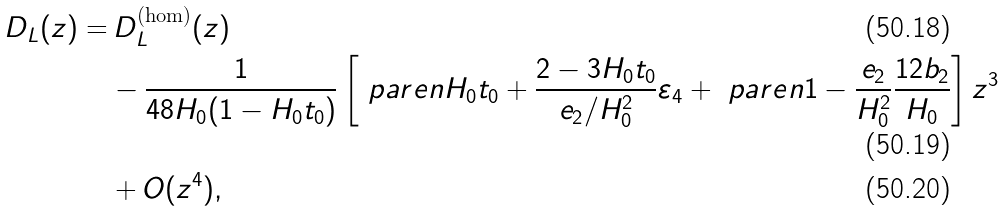Convert formula to latex. <formula><loc_0><loc_0><loc_500><loc_500>D _ { L } ( z ) = & \, D _ { L } ^ { \text {(hom)} } ( z ) \\ & - \frac { 1 } { 4 8 H _ { 0 } ( 1 - H _ { 0 } t _ { 0 } ) } \left [ \ p a r e n { H _ { 0 } t _ { 0 } + \frac { 2 - 3 H _ { 0 } t _ { 0 } } { e _ { 2 } / H _ { 0 } ^ { 2 } } } \varepsilon _ { 4 } + \ p a r e n { 1 - \frac { e _ { 2 } } { H _ { 0 } ^ { 2 } } } \frac { 1 2 b _ { 2 } } { H _ { 0 } } \right ] z ^ { 3 } \\ & + O ( z ^ { 4 } ) ,</formula> 